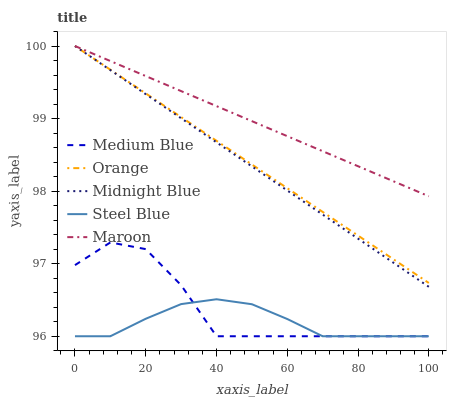Does Steel Blue have the minimum area under the curve?
Answer yes or no. Yes. Does Maroon have the maximum area under the curve?
Answer yes or no. Yes. Does Medium Blue have the minimum area under the curve?
Answer yes or no. No. Does Medium Blue have the maximum area under the curve?
Answer yes or no. No. Is Maroon the smoothest?
Answer yes or no. Yes. Is Medium Blue the roughest?
Answer yes or no. Yes. Is Midnight Blue the smoothest?
Answer yes or no. No. Is Midnight Blue the roughest?
Answer yes or no. No. Does Medium Blue have the lowest value?
Answer yes or no. Yes. Does Midnight Blue have the lowest value?
Answer yes or no. No. Does Maroon have the highest value?
Answer yes or no. Yes. Does Medium Blue have the highest value?
Answer yes or no. No. Is Steel Blue less than Orange?
Answer yes or no. Yes. Is Orange greater than Steel Blue?
Answer yes or no. Yes. Does Medium Blue intersect Steel Blue?
Answer yes or no. Yes. Is Medium Blue less than Steel Blue?
Answer yes or no. No. Is Medium Blue greater than Steel Blue?
Answer yes or no. No. Does Steel Blue intersect Orange?
Answer yes or no. No. 